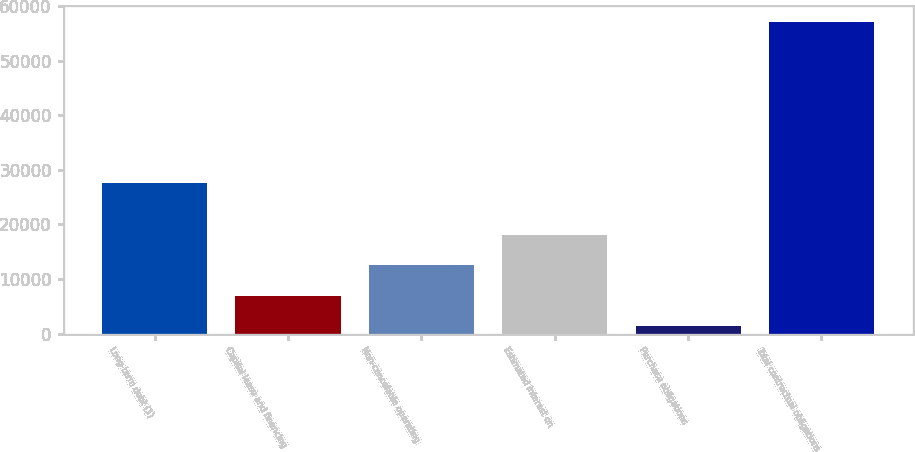Convert chart to OTSL. <chart><loc_0><loc_0><loc_500><loc_500><bar_chart><fcel>Long-term debt (1)<fcel>Capital lease and financing<fcel>Non-cancelable operating<fcel>Estimated interest on<fcel>Purchase obligations<fcel>Total contractual obligations<nl><fcel>27654<fcel>6911.8<fcel>12495.6<fcel>18079.4<fcel>1328<fcel>57166<nl></chart> 